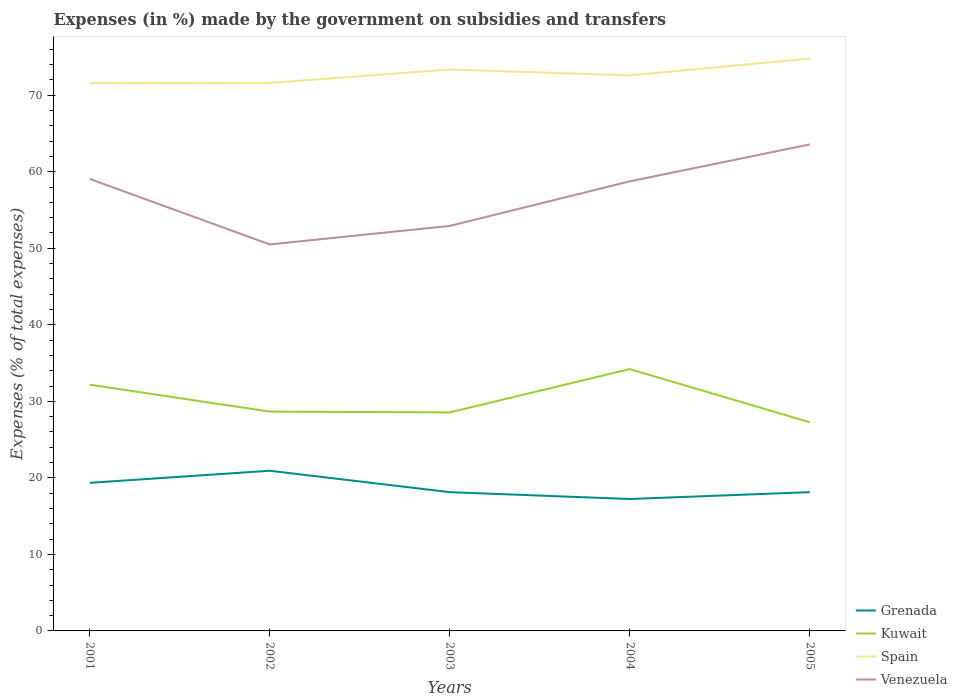Does the line corresponding to Kuwait intersect with the line corresponding to Spain?
Your answer should be very brief. No. Across all years, what is the maximum percentage of expenses made by the government on subsidies and transfers in Spain?
Make the answer very short. 71.59. What is the total percentage of expenses made by the government on subsidies and transfers in Spain in the graph?
Give a very brief answer. -1.78. What is the difference between the highest and the second highest percentage of expenses made by the government on subsidies and transfers in Spain?
Provide a short and direct response. 3.2. Is the percentage of expenses made by the government on subsidies and transfers in Spain strictly greater than the percentage of expenses made by the government on subsidies and transfers in Venezuela over the years?
Your answer should be very brief. No. How many years are there in the graph?
Your response must be concise. 5. Does the graph contain any zero values?
Keep it short and to the point. No. Does the graph contain grids?
Provide a succinct answer. No. How many legend labels are there?
Keep it short and to the point. 4. How are the legend labels stacked?
Offer a terse response. Vertical. What is the title of the graph?
Make the answer very short. Expenses (in %) made by the government on subsidies and transfers. Does "Virgin Islands" appear as one of the legend labels in the graph?
Offer a terse response. No. What is the label or title of the X-axis?
Your answer should be very brief. Years. What is the label or title of the Y-axis?
Ensure brevity in your answer.  Expenses (% of total expenses). What is the Expenses (% of total expenses) in Grenada in 2001?
Your answer should be very brief. 19.35. What is the Expenses (% of total expenses) in Kuwait in 2001?
Your answer should be very brief. 32.18. What is the Expenses (% of total expenses) in Spain in 2001?
Your response must be concise. 71.59. What is the Expenses (% of total expenses) in Venezuela in 2001?
Provide a short and direct response. 59.06. What is the Expenses (% of total expenses) in Grenada in 2002?
Your answer should be very brief. 20.93. What is the Expenses (% of total expenses) of Kuwait in 2002?
Offer a very short reply. 28.66. What is the Expenses (% of total expenses) in Spain in 2002?
Provide a short and direct response. 71.61. What is the Expenses (% of total expenses) in Venezuela in 2002?
Provide a succinct answer. 50.5. What is the Expenses (% of total expenses) of Grenada in 2003?
Keep it short and to the point. 18.13. What is the Expenses (% of total expenses) in Kuwait in 2003?
Keep it short and to the point. 28.55. What is the Expenses (% of total expenses) of Spain in 2003?
Keep it short and to the point. 73.37. What is the Expenses (% of total expenses) of Venezuela in 2003?
Offer a very short reply. 52.92. What is the Expenses (% of total expenses) in Grenada in 2004?
Make the answer very short. 17.24. What is the Expenses (% of total expenses) of Kuwait in 2004?
Ensure brevity in your answer.  34.22. What is the Expenses (% of total expenses) in Spain in 2004?
Keep it short and to the point. 72.6. What is the Expenses (% of total expenses) in Venezuela in 2004?
Keep it short and to the point. 58.75. What is the Expenses (% of total expenses) in Grenada in 2005?
Provide a short and direct response. 18.13. What is the Expenses (% of total expenses) of Kuwait in 2005?
Provide a short and direct response. 27.27. What is the Expenses (% of total expenses) of Spain in 2005?
Offer a very short reply. 74.79. What is the Expenses (% of total expenses) in Venezuela in 2005?
Your answer should be very brief. 63.57. Across all years, what is the maximum Expenses (% of total expenses) in Grenada?
Provide a short and direct response. 20.93. Across all years, what is the maximum Expenses (% of total expenses) of Kuwait?
Your answer should be very brief. 34.22. Across all years, what is the maximum Expenses (% of total expenses) in Spain?
Offer a terse response. 74.79. Across all years, what is the maximum Expenses (% of total expenses) of Venezuela?
Offer a very short reply. 63.57. Across all years, what is the minimum Expenses (% of total expenses) in Grenada?
Make the answer very short. 17.24. Across all years, what is the minimum Expenses (% of total expenses) of Kuwait?
Ensure brevity in your answer.  27.27. Across all years, what is the minimum Expenses (% of total expenses) in Spain?
Your answer should be compact. 71.59. Across all years, what is the minimum Expenses (% of total expenses) of Venezuela?
Provide a succinct answer. 50.5. What is the total Expenses (% of total expenses) in Grenada in the graph?
Offer a terse response. 93.78. What is the total Expenses (% of total expenses) of Kuwait in the graph?
Provide a short and direct response. 150.87. What is the total Expenses (% of total expenses) of Spain in the graph?
Make the answer very short. 363.95. What is the total Expenses (% of total expenses) of Venezuela in the graph?
Give a very brief answer. 284.81. What is the difference between the Expenses (% of total expenses) of Grenada in 2001 and that in 2002?
Ensure brevity in your answer.  -1.58. What is the difference between the Expenses (% of total expenses) in Kuwait in 2001 and that in 2002?
Your answer should be compact. 3.52. What is the difference between the Expenses (% of total expenses) in Spain in 2001 and that in 2002?
Provide a short and direct response. -0.02. What is the difference between the Expenses (% of total expenses) of Venezuela in 2001 and that in 2002?
Give a very brief answer. 8.56. What is the difference between the Expenses (% of total expenses) in Grenada in 2001 and that in 2003?
Provide a short and direct response. 1.22. What is the difference between the Expenses (% of total expenses) in Kuwait in 2001 and that in 2003?
Offer a very short reply. 3.62. What is the difference between the Expenses (% of total expenses) in Spain in 2001 and that in 2003?
Provide a succinct answer. -1.78. What is the difference between the Expenses (% of total expenses) of Venezuela in 2001 and that in 2003?
Your response must be concise. 6.14. What is the difference between the Expenses (% of total expenses) of Grenada in 2001 and that in 2004?
Ensure brevity in your answer.  2.11. What is the difference between the Expenses (% of total expenses) of Kuwait in 2001 and that in 2004?
Provide a short and direct response. -2.04. What is the difference between the Expenses (% of total expenses) of Spain in 2001 and that in 2004?
Keep it short and to the point. -1.01. What is the difference between the Expenses (% of total expenses) of Venezuela in 2001 and that in 2004?
Keep it short and to the point. 0.32. What is the difference between the Expenses (% of total expenses) of Grenada in 2001 and that in 2005?
Provide a short and direct response. 1.22. What is the difference between the Expenses (% of total expenses) of Kuwait in 2001 and that in 2005?
Your response must be concise. 4.91. What is the difference between the Expenses (% of total expenses) in Spain in 2001 and that in 2005?
Offer a terse response. -3.2. What is the difference between the Expenses (% of total expenses) of Venezuela in 2001 and that in 2005?
Offer a terse response. -4.51. What is the difference between the Expenses (% of total expenses) of Grenada in 2002 and that in 2003?
Provide a short and direct response. 2.8. What is the difference between the Expenses (% of total expenses) of Kuwait in 2002 and that in 2003?
Keep it short and to the point. 0.11. What is the difference between the Expenses (% of total expenses) of Spain in 2002 and that in 2003?
Offer a very short reply. -1.76. What is the difference between the Expenses (% of total expenses) of Venezuela in 2002 and that in 2003?
Give a very brief answer. -2.42. What is the difference between the Expenses (% of total expenses) of Grenada in 2002 and that in 2004?
Provide a succinct answer. 3.69. What is the difference between the Expenses (% of total expenses) of Kuwait in 2002 and that in 2004?
Offer a terse response. -5.55. What is the difference between the Expenses (% of total expenses) in Spain in 2002 and that in 2004?
Provide a succinct answer. -0.99. What is the difference between the Expenses (% of total expenses) in Venezuela in 2002 and that in 2004?
Keep it short and to the point. -8.24. What is the difference between the Expenses (% of total expenses) in Grenada in 2002 and that in 2005?
Your answer should be very brief. 2.8. What is the difference between the Expenses (% of total expenses) of Kuwait in 2002 and that in 2005?
Ensure brevity in your answer.  1.39. What is the difference between the Expenses (% of total expenses) of Spain in 2002 and that in 2005?
Keep it short and to the point. -3.18. What is the difference between the Expenses (% of total expenses) of Venezuela in 2002 and that in 2005?
Give a very brief answer. -13.07. What is the difference between the Expenses (% of total expenses) of Grenada in 2003 and that in 2004?
Offer a terse response. 0.89. What is the difference between the Expenses (% of total expenses) of Kuwait in 2003 and that in 2004?
Make the answer very short. -5.66. What is the difference between the Expenses (% of total expenses) in Spain in 2003 and that in 2004?
Offer a terse response. 0.77. What is the difference between the Expenses (% of total expenses) of Venezuela in 2003 and that in 2004?
Provide a short and direct response. -5.82. What is the difference between the Expenses (% of total expenses) in Grenada in 2003 and that in 2005?
Offer a terse response. -0. What is the difference between the Expenses (% of total expenses) in Kuwait in 2003 and that in 2005?
Your answer should be compact. 1.29. What is the difference between the Expenses (% of total expenses) of Spain in 2003 and that in 2005?
Give a very brief answer. -1.42. What is the difference between the Expenses (% of total expenses) in Venezuela in 2003 and that in 2005?
Offer a terse response. -10.65. What is the difference between the Expenses (% of total expenses) of Grenada in 2004 and that in 2005?
Your answer should be compact. -0.9. What is the difference between the Expenses (% of total expenses) of Kuwait in 2004 and that in 2005?
Your answer should be compact. 6.95. What is the difference between the Expenses (% of total expenses) of Spain in 2004 and that in 2005?
Offer a terse response. -2.19. What is the difference between the Expenses (% of total expenses) in Venezuela in 2004 and that in 2005?
Keep it short and to the point. -4.83. What is the difference between the Expenses (% of total expenses) in Grenada in 2001 and the Expenses (% of total expenses) in Kuwait in 2002?
Your response must be concise. -9.31. What is the difference between the Expenses (% of total expenses) in Grenada in 2001 and the Expenses (% of total expenses) in Spain in 2002?
Your response must be concise. -52.26. What is the difference between the Expenses (% of total expenses) in Grenada in 2001 and the Expenses (% of total expenses) in Venezuela in 2002?
Your answer should be very brief. -31.15. What is the difference between the Expenses (% of total expenses) in Kuwait in 2001 and the Expenses (% of total expenses) in Spain in 2002?
Keep it short and to the point. -39.43. What is the difference between the Expenses (% of total expenses) of Kuwait in 2001 and the Expenses (% of total expenses) of Venezuela in 2002?
Give a very brief answer. -18.33. What is the difference between the Expenses (% of total expenses) of Spain in 2001 and the Expenses (% of total expenses) of Venezuela in 2002?
Keep it short and to the point. 21.08. What is the difference between the Expenses (% of total expenses) of Grenada in 2001 and the Expenses (% of total expenses) of Kuwait in 2003?
Provide a succinct answer. -9.2. What is the difference between the Expenses (% of total expenses) of Grenada in 2001 and the Expenses (% of total expenses) of Spain in 2003?
Provide a succinct answer. -54.02. What is the difference between the Expenses (% of total expenses) of Grenada in 2001 and the Expenses (% of total expenses) of Venezuela in 2003?
Make the answer very short. -33.57. What is the difference between the Expenses (% of total expenses) of Kuwait in 2001 and the Expenses (% of total expenses) of Spain in 2003?
Keep it short and to the point. -41.19. What is the difference between the Expenses (% of total expenses) of Kuwait in 2001 and the Expenses (% of total expenses) of Venezuela in 2003?
Provide a succinct answer. -20.74. What is the difference between the Expenses (% of total expenses) in Spain in 2001 and the Expenses (% of total expenses) in Venezuela in 2003?
Give a very brief answer. 18.66. What is the difference between the Expenses (% of total expenses) of Grenada in 2001 and the Expenses (% of total expenses) of Kuwait in 2004?
Your answer should be compact. -14.87. What is the difference between the Expenses (% of total expenses) of Grenada in 2001 and the Expenses (% of total expenses) of Spain in 2004?
Provide a short and direct response. -53.25. What is the difference between the Expenses (% of total expenses) of Grenada in 2001 and the Expenses (% of total expenses) of Venezuela in 2004?
Make the answer very short. -39.4. What is the difference between the Expenses (% of total expenses) of Kuwait in 2001 and the Expenses (% of total expenses) of Spain in 2004?
Provide a short and direct response. -40.42. What is the difference between the Expenses (% of total expenses) of Kuwait in 2001 and the Expenses (% of total expenses) of Venezuela in 2004?
Give a very brief answer. -26.57. What is the difference between the Expenses (% of total expenses) in Spain in 2001 and the Expenses (% of total expenses) in Venezuela in 2004?
Offer a very short reply. 12.84. What is the difference between the Expenses (% of total expenses) of Grenada in 2001 and the Expenses (% of total expenses) of Kuwait in 2005?
Make the answer very short. -7.92. What is the difference between the Expenses (% of total expenses) of Grenada in 2001 and the Expenses (% of total expenses) of Spain in 2005?
Provide a succinct answer. -55.44. What is the difference between the Expenses (% of total expenses) of Grenada in 2001 and the Expenses (% of total expenses) of Venezuela in 2005?
Keep it short and to the point. -44.22. What is the difference between the Expenses (% of total expenses) in Kuwait in 2001 and the Expenses (% of total expenses) in Spain in 2005?
Offer a terse response. -42.61. What is the difference between the Expenses (% of total expenses) in Kuwait in 2001 and the Expenses (% of total expenses) in Venezuela in 2005?
Provide a succinct answer. -31.39. What is the difference between the Expenses (% of total expenses) of Spain in 2001 and the Expenses (% of total expenses) of Venezuela in 2005?
Offer a terse response. 8.01. What is the difference between the Expenses (% of total expenses) of Grenada in 2002 and the Expenses (% of total expenses) of Kuwait in 2003?
Make the answer very short. -7.62. What is the difference between the Expenses (% of total expenses) in Grenada in 2002 and the Expenses (% of total expenses) in Spain in 2003?
Provide a short and direct response. -52.43. What is the difference between the Expenses (% of total expenses) of Grenada in 2002 and the Expenses (% of total expenses) of Venezuela in 2003?
Make the answer very short. -31.99. What is the difference between the Expenses (% of total expenses) of Kuwait in 2002 and the Expenses (% of total expenses) of Spain in 2003?
Your response must be concise. -44.71. What is the difference between the Expenses (% of total expenses) of Kuwait in 2002 and the Expenses (% of total expenses) of Venezuela in 2003?
Provide a succinct answer. -24.26. What is the difference between the Expenses (% of total expenses) of Spain in 2002 and the Expenses (% of total expenses) of Venezuela in 2003?
Give a very brief answer. 18.69. What is the difference between the Expenses (% of total expenses) in Grenada in 2002 and the Expenses (% of total expenses) in Kuwait in 2004?
Provide a short and direct response. -13.28. What is the difference between the Expenses (% of total expenses) of Grenada in 2002 and the Expenses (% of total expenses) of Spain in 2004?
Your response must be concise. -51.67. What is the difference between the Expenses (% of total expenses) of Grenada in 2002 and the Expenses (% of total expenses) of Venezuela in 2004?
Your response must be concise. -37.81. What is the difference between the Expenses (% of total expenses) in Kuwait in 2002 and the Expenses (% of total expenses) in Spain in 2004?
Your answer should be compact. -43.94. What is the difference between the Expenses (% of total expenses) in Kuwait in 2002 and the Expenses (% of total expenses) in Venezuela in 2004?
Keep it short and to the point. -30.09. What is the difference between the Expenses (% of total expenses) of Spain in 2002 and the Expenses (% of total expenses) of Venezuela in 2004?
Provide a succinct answer. 12.86. What is the difference between the Expenses (% of total expenses) in Grenada in 2002 and the Expenses (% of total expenses) in Kuwait in 2005?
Provide a short and direct response. -6.33. What is the difference between the Expenses (% of total expenses) in Grenada in 2002 and the Expenses (% of total expenses) in Spain in 2005?
Make the answer very short. -53.86. What is the difference between the Expenses (% of total expenses) of Grenada in 2002 and the Expenses (% of total expenses) of Venezuela in 2005?
Give a very brief answer. -42.64. What is the difference between the Expenses (% of total expenses) of Kuwait in 2002 and the Expenses (% of total expenses) of Spain in 2005?
Your answer should be very brief. -46.13. What is the difference between the Expenses (% of total expenses) of Kuwait in 2002 and the Expenses (% of total expenses) of Venezuela in 2005?
Give a very brief answer. -34.91. What is the difference between the Expenses (% of total expenses) in Spain in 2002 and the Expenses (% of total expenses) in Venezuela in 2005?
Your response must be concise. 8.04. What is the difference between the Expenses (% of total expenses) in Grenada in 2003 and the Expenses (% of total expenses) in Kuwait in 2004?
Your answer should be very brief. -16.08. What is the difference between the Expenses (% of total expenses) in Grenada in 2003 and the Expenses (% of total expenses) in Spain in 2004?
Ensure brevity in your answer.  -54.47. What is the difference between the Expenses (% of total expenses) of Grenada in 2003 and the Expenses (% of total expenses) of Venezuela in 2004?
Keep it short and to the point. -40.62. What is the difference between the Expenses (% of total expenses) of Kuwait in 2003 and the Expenses (% of total expenses) of Spain in 2004?
Offer a terse response. -44.04. What is the difference between the Expenses (% of total expenses) of Kuwait in 2003 and the Expenses (% of total expenses) of Venezuela in 2004?
Provide a short and direct response. -30.19. What is the difference between the Expenses (% of total expenses) in Spain in 2003 and the Expenses (% of total expenses) in Venezuela in 2004?
Provide a short and direct response. 14.62. What is the difference between the Expenses (% of total expenses) in Grenada in 2003 and the Expenses (% of total expenses) in Kuwait in 2005?
Make the answer very short. -9.14. What is the difference between the Expenses (% of total expenses) in Grenada in 2003 and the Expenses (% of total expenses) in Spain in 2005?
Offer a very short reply. -56.66. What is the difference between the Expenses (% of total expenses) of Grenada in 2003 and the Expenses (% of total expenses) of Venezuela in 2005?
Make the answer very short. -45.44. What is the difference between the Expenses (% of total expenses) in Kuwait in 2003 and the Expenses (% of total expenses) in Spain in 2005?
Offer a very short reply. -46.23. What is the difference between the Expenses (% of total expenses) in Kuwait in 2003 and the Expenses (% of total expenses) in Venezuela in 2005?
Provide a succinct answer. -35.02. What is the difference between the Expenses (% of total expenses) of Spain in 2003 and the Expenses (% of total expenses) of Venezuela in 2005?
Give a very brief answer. 9.79. What is the difference between the Expenses (% of total expenses) of Grenada in 2004 and the Expenses (% of total expenses) of Kuwait in 2005?
Provide a succinct answer. -10.03. What is the difference between the Expenses (% of total expenses) of Grenada in 2004 and the Expenses (% of total expenses) of Spain in 2005?
Provide a succinct answer. -57.55. What is the difference between the Expenses (% of total expenses) of Grenada in 2004 and the Expenses (% of total expenses) of Venezuela in 2005?
Offer a terse response. -46.33. What is the difference between the Expenses (% of total expenses) in Kuwait in 2004 and the Expenses (% of total expenses) in Spain in 2005?
Give a very brief answer. -40.57. What is the difference between the Expenses (% of total expenses) in Kuwait in 2004 and the Expenses (% of total expenses) in Venezuela in 2005?
Provide a short and direct response. -29.36. What is the difference between the Expenses (% of total expenses) of Spain in 2004 and the Expenses (% of total expenses) of Venezuela in 2005?
Keep it short and to the point. 9.02. What is the average Expenses (% of total expenses) of Grenada per year?
Provide a succinct answer. 18.76. What is the average Expenses (% of total expenses) of Kuwait per year?
Provide a succinct answer. 30.18. What is the average Expenses (% of total expenses) in Spain per year?
Your response must be concise. 72.79. What is the average Expenses (% of total expenses) in Venezuela per year?
Give a very brief answer. 56.96. In the year 2001, what is the difference between the Expenses (% of total expenses) in Grenada and Expenses (% of total expenses) in Kuwait?
Provide a short and direct response. -12.83. In the year 2001, what is the difference between the Expenses (% of total expenses) in Grenada and Expenses (% of total expenses) in Spain?
Your answer should be compact. -52.24. In the year 2001, what is the difference between the Expenses (% of total expenses) in Grenada and Expenses (% of total expenses) in Venezuela?
Provide a short and direct response. -39.71. In the year 2001, what is the difference between the Expenses (% of total expenses) of Kuwait and Expenses (% of total expenses) of Spain?
Offer a terse response. -39.41. In the year 2001, what is the difference between the Expenses (% of total expenses) of Kuwait and Expenses (% of total expenses) of Venezuela?
Provide a succinct answer. -26.89. In the year 2001, what is the difference between the Expenses (% of total expenses) of Spain and Expenses (% of total expenses) of Venezuela?
Provide a succinct answer. 12.52. In the year 2002, what is the difference between the Expenses (% of total expenses) of Grenada and Expenses (% of total expenses) of Kuwait?
Provide a succinct answer. -7.73. In the year 2002, what is the difference between the Expenses (% of total expenses) in Grenada and Expenses (% of total expenses) in Spain?
Provide a short and direct response. -50.68. In the year 2002, what is the difference between the Expenses (% of total expenses) in Grenada and Expenses (% of total expenses) in Venezuela?
Ensure brevity in your answer.  -29.57. In the year 2002, what is the difference between the Expenses (% of total expenses) in Kuwait and Expenses (% of total expenses) in Spain?
Make the answer very short. -42.95. In the year 2002, what is the difference between the Expenses (% of total expenses) of Kuwait and Expenses (% of total expenses) of Venezuela?
Make the answer very short. -21.84. In the year 2002, what is the difference between the Expenses (% of total expenses) of Spain and Expenses (% of total expenses) of Venezuela?
Provide a succinct answer. 21.11. In the year 2003, what is the difference between the Expenses (% of total expenses) of Grenada and Expenses (% of total expenses) of Kuwait?
Ensure brevity in your answer.  -10.42. In the year 2003, what is the difference between the Expenses (% of total expenses) in Grenada and Expenses (% of total expenses) in Spain?
Make the answer very short. -55.23. In the year 2003, what is the difference between the Expenses (% of total expenses) in Grenada and Expenses (% of total expenses) in Venezuela?
Make the answer very short. -34.79. In the year 2003, what is the difference between the Expenses (% of total expenses) in Kuwait and Expenses (% of total expenses) in Spain?
Give a very brief answer. -44.81. In the year 2003, what is the difference between the Expenses (% of total expenses) of Kuwait and Expenses (% of total expenses) of Venezuela?
Keep it short and to the point. -24.37. In the year 2003, what is the difference between the Expenses (% of total expenses) in Spain and Expenses (% of total expenses) in Venezuela?
Provide a short and direct response. 20.44. In the year 2004, what is the difference between the Expenses (% of total expenses) of Grenada and Expenses (% of total expenses) of Kuwait?
Your response must be concise. -16.98. In the year 2004, what is the difference between the Expenses (% of total expenses) in Grenada and Expenses (% of total expenses) in Spain?
Provide a succinct answer. -55.36. In the year 2004, what is the difference between the Expenses (% of total expenses) in Grenada and Expenses (% of total expenses) in Venezuela?
Provide a short and direct response. -41.51. In the year 2004, what is the difference between the Expenses (% of total expenses) in Kuwait and Expenses (% of total expenses) in Spain?
Offer a terse response. -38.38. In the year 2004, what is the difference between the Expenses (% of total expenses) in Kuwait and Expenses (% of total expenses) in Venezuela?
Your response must be concise. -24.53. In the year 2004, what is the difference between the Expenses (% of total expenses) in Spain and Expenses (% of total expenses) in Venezuela?
Provide a succinct answer. 13.85. In the year 2005, what is the difference between the Expenses (% of total expenses) in Grenada and Expenses (% of total expenses) in Kuwait?
Offer a very short reply. -9.13. In the year 2005, what is the difference between the Expenses (% of total expenses) of Grenada and Expenses (% of total expenses) of Spain?
Make the answer very short. -56.65. In the year 2005, what is the difference between the Expenses (% of total expenses) of Grenada and Expenses (% of total expenses) of Venezuela?
Your answer should be very brief. -45.44. In the year 2005, what is the difference between the Expenses (% of total expenses) of Kuwait and Expenses (% of total expenses) of Spain?
Your answer should be compact. -47.52. In the year 2005, what is the difference between the Expenses (% of total expenses) of Kuwait and Expenses (% of total expenses) of Venezuela?
Provide a succinct answer. -36.31. In the year 2005, what is the difference between the Expenses (% of total expenses) in Spain and Expenses (% of total expenses) in Venezuela?
Your answer should be compact. 11.21. What is the ratio of the Expenses (% of total expenses) in Grenada in 2001 to that in 2002?
Your answer should be compact. 0.92. What is the ratio of the Expenses (% of total expenses) in Kuwait in 2001 to that in 2002?
Your answer should be compact. 1.12. What is the ratio of the Expenses (% of total expenses) in Spain in 2001 to that in 2002?
Offer a terse response. 1. What is the ratio of the Expenses (% of total expenses) in Venezuela in 2001 to that in 2002?
Give a very brief answer. 1.17. What is the ratio of the Expenses (% of total expenses) in Grenada in 2001 to that in 2003?
Offer a very short reply. 1.07. What is the ratio of the Expenses (% of total expenses) of Kuwait in 2001 to that in 2003?
Offer a very short reply. 1.13. What is the ratio of the Expenses (% of total expenses) in Spain in 2001 to that in 2003?
Make the answer very short. 0.98. What is the ratio of the Expenses (% of total expenses) in Venezuela in 2001 to that in 2003?
Ensure brevity in your answer.  1.12. What is the ratio of the Expenses (% of total expenses) of Grenada in 2001 to that in 2004?
Offer a terse response. 1.12. What is the ratio of the Expenses (% of total expenses) in Kuwait in 2001 to that in 2004?
Your answer should be compact. 0.94. What is the ratio of the Expenses (% of total expenses) of Spain in 2001 to that in 2004?
Your answer should be compact. 0.99. What is the ratio of the Expenses (% of total expenses) in Venezuela in 2001 to that in 2004?
Ensure brevity in your answer.  1.01. What is the ratio of the Expenses (% of total expenses) in Grenada in 2001 to that in 2005?
Give a very brief answer. 1.07. What is the ratio of the Expenses (% of total expenses) of Kuwait in 2001 to that in 2005?
Your response must be concise. 1.18. What is the ratio of the Expenses (% of total expenses) in Spain in 2001 to that in 2005?
Keep it short and to the point. 0.96. What is the ratio of the Expenses (% of total expenses) in Venezuela in 2001 to that in 2005?
Give a very brief answer. 0.93. What is the ratio of the Expenses (% of total expenses) of Grenada in 2002 to that in 2003?
Provide a short and direct response. 1.15. What is the ratio of the Expenses (% of total expenses) of Spain in 2002 to that in 2003?
Your response must be concise. 0.98. What is the ratio of the Expenses (% of total expenses) in Venezuela in 2002 to that in 2003?
Give a very brief answer. 0.95. What is the ratio of the Expenses (% of total expenses) in Grenada in 2002 to that in 2004?
Make the answer very short. 1.21. What is the ratio of the Expenses (% of total expenses) in Kuwait in 2002 to that in 2004?
Offer a terse response. 0.84. What is the ratio of the Expenses (% of total expenses) of Spain in 2002 to that in 2004?
Offer a very short reply. 0.99. What is the ratio of the Expenses (% of total expenses) in Venezuela in 2002 to that in 2004?
Your answer should be compact. 0.86. What is the ratio of the Expenses (% of total expenses) of Grenada in 2002 to that in 2005?
Your answer should be compact. 1.15. What is the ratio of the Expenses (% of total expenses) in Kuwait in 2002 to that in 2005?
Your answer should be very brief. 1.05. What is the ratio of the Expenses (% of total expenses) in Spain in 2002 to that in 2005?
Ensure brevity in your answer.  0.96. What is the ratio of the Expenses (% of total expenses) in Venezuela in 2002 to that in 2005?
Your answer should be compact. 0.79. What is the ratio of the Expenses (% of total expenses) of Grenada in 2003 to that in 2004?
Offer a very short reply. 1.05. What is the ratio of the Expenses (% of total expenses) in Kuwait in 2003 to that in 2004?
Offer a terse response. 0.83. What is the ratio of the Expenses (% of total expenses) of Spain in 2003 to that in 2004?
Offer a very short reply. 1.01. What is the ratio of the Expenses (% of total expenses) in Venezuela in 2003 to that in 2004?
Your response must be concise. 0.9. What is the ratio of the Expenses (% of total expenses) of Grenada in 2003 to that in 2005?
Provide a succinct answer. 1. What is the ratio of the Expenses (% of total expenses) of Kuwait in 2003 to that in 2005?
Your answer should be compact. 1.05. What is the ratio of the Expenses (% of total expenses) of Spain in 2003 to that in 2005?
Give a very brief answer. 0.98. What is the ratio of the Expenses (% of total expenses) in Venezuela in 2003 to that in 2005?
Make the answer very short. 0.83. What is the ratio of the Expenses (% of total expenses) of Grenada in 2004 to that in 2005?
Ensure brevity in your answer.  0.95. What is the ratio of the Expenses (% of total expenses) of Kuwait in 2004 to that in 2005?
Keep it short and to the point. 1.25. What is the ratio of the Expenses (% of total expenses) of Spain in 2004 to that in 2005?
Your answer should be compact. 0.97. What is the ratio of the Expenses (% of total expenses) of Venezuela in 2004 to that in 2005?
Provide a succinct answer. 0.92. What is the difference between the highest and the second highest Expenses (% of total expenses) in Grenada?
Keep it short and to the point. 1.58. What is the difference between the highest and the second highest Expenses (% of total expenses) in Kuwait?
Give a very brief answer. 2.04. What is the difference between the highest and the second highest Expenses (% of total expenses) of Spain?
Make the answer very short. 1.42. What is the difference between the highest and the second highest Expenses (% of total expenses) in Venezuela?
Your answer should be very brief. 4.51. What is the difference between the highest and the lowest Expenses (% of total expenses) in Grenada?
Keep it short and to the point. 3.69. What is the difference between the highest and the lowest Expenses (% of total expenses) of Kuwait?
Your answer should be very brief. 6.95. What is the difference between the highest and the lowest Expenses (% of total expenses) in Spain?
Offer a terse response. 3.2. What is the difference between the highest and the lowest Expenses (% of total expenses) in Venezuela?
Provide a succinct answer. 13.07. 